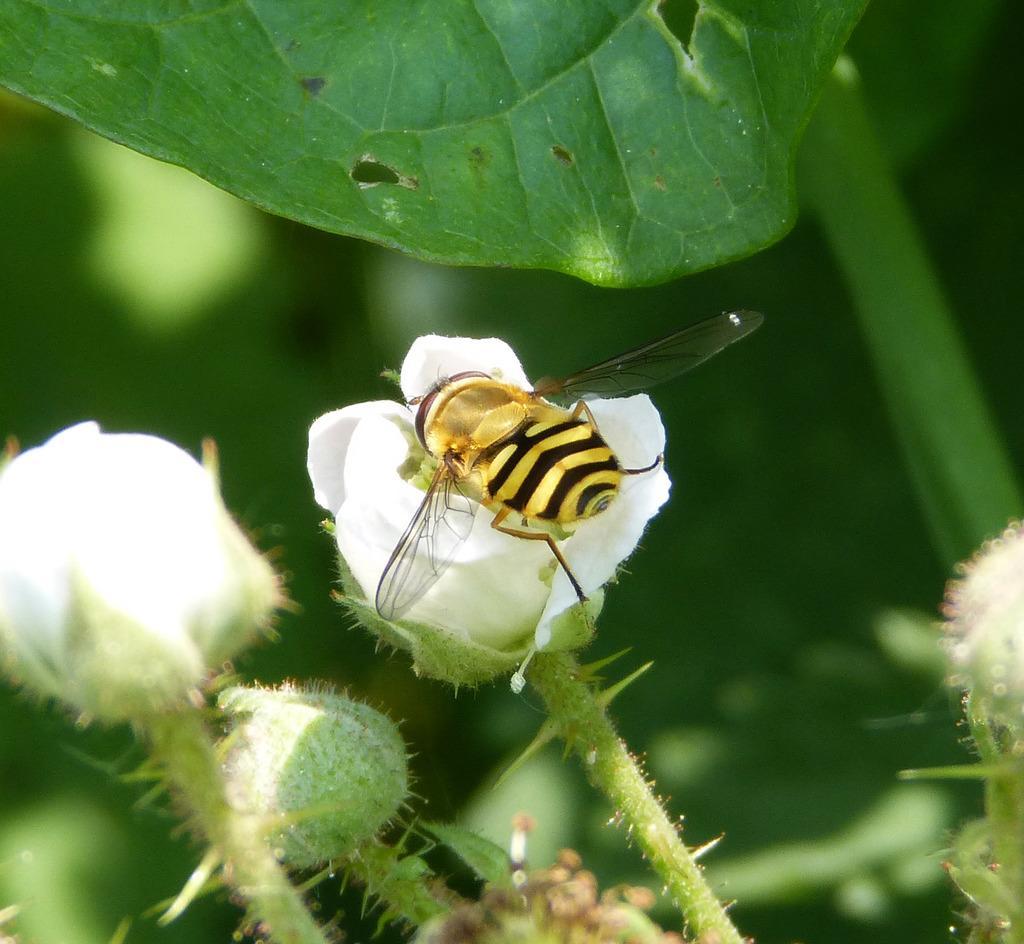Can you describe this image briefly? In this image we can see some white color flowers and there is a bee on a flower, we can see the leaves and the background is blurred. 